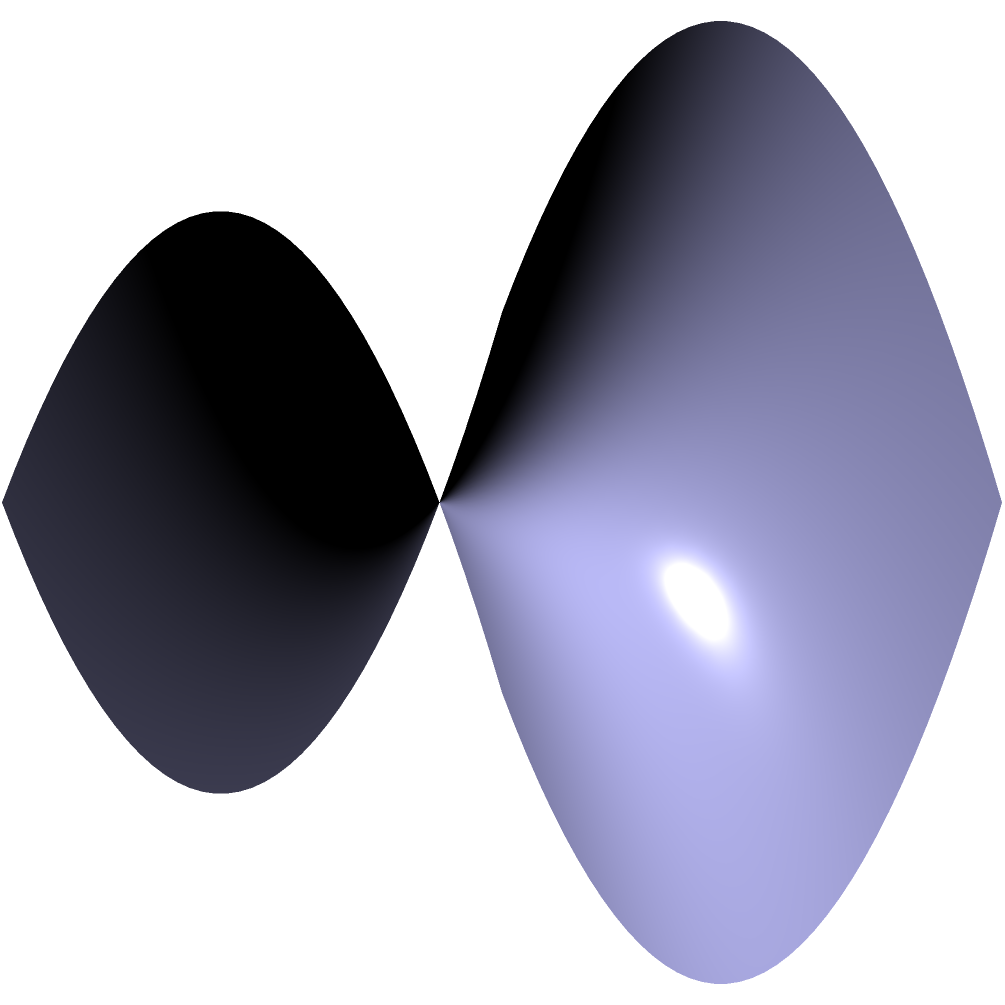In the context of network topology optimization, consider two parallel lines on a saddle-shaped surface, as shown in the diagram. If these lines represent data paths in a non-Euclidean network space, how would their behavior differ from parallel lines in Euclidean space, and what implications might this have for data routing in ARRIS network infrastructure? To understand the behavior of parallel lines on a saddle-shaped surface and its implications for network infrastructure, let's follow these steps:

1. In Euclidean geometry, parallel lines maintain a constant distance and never intersect. However, on a saddle-shaped surface (a hyperbolic surface), this property doesn't hold.

2. On a saddle surface, which is negatively curved, parallel lines diverge from each other. This is known as hyperbolic geometry.

3. The divergence occurs because the surface curves away from itself in opposite directions, like a saddle or the shape of a Pringles chip.

4. In the context of network topology:
   a) The saddle surface represents a non-Euclidean network space.
   b) The parallel lines represent data paths or communication channels.

5. Implications for data routing in ARRIS network infrastructure:
   a) Increased path diversity: As paths diverge, there are more potential routes for data to travel, potentially improving load balancing and redundancy.
   b) Dynamic routing challenges: Traditional routing algorithms based on Euclidean assumptions may not work optimally in this space.
   c) Opportunity for improved efficiency: By leveraging the properties of hyperbolic geometry, it might be possible to design more efficient routing protocols.
   d) Scalability: Hyperbolic spaces can represent exponentially growing networks more efficiently than Euclidean spaces.

6. Practical considerations:
   a) ARRIS could potentially develop routing algorithms that take advantage of hyperbolic geometry for more efficient data transmission.
   b) Network visualization tools might need to be adapted to accurately represent the topology in this non-Euclidean space.
   c) Quality of Service (QoS) metrics may need to be redefined to account for the diverging nature of parallel paths.

Understanding these concepts could lead to innovative approaches in network design and optimization for telecommunications infrastructure.
Answer: Parallel lines diverge, offering increased path diversity and potential for optimized routing algorithms in non-Euclidean network topologies. 